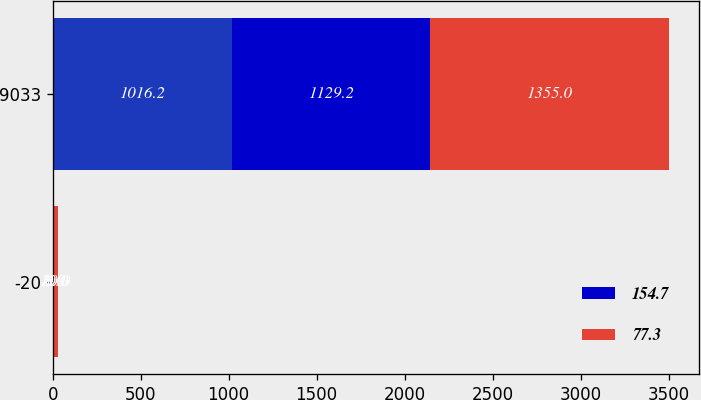Convert chart. <chart><loc_0><loc_0><loc_500><loc_500><stacked_bar_chart><ecel><fcel>-20<fcel>9033<nl><fcel>nan<fcel>10<fcel>1016.2<nl><fcel>154.7<fcel>0<fcel>1129.2<nl><fcel>77.3<fcel>20<fcel>1355<nl></chart> 